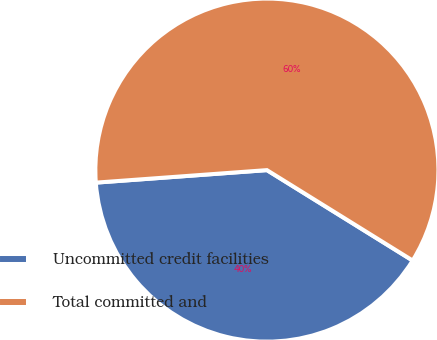<chart> <loc_0><loc_0><loc_500><loc_500><pie_chart><fcel>Uncommitted credit facilities<fcel>Total committed and<nl><fcel>40.0%<fcel>60.0%<nl></chart> 